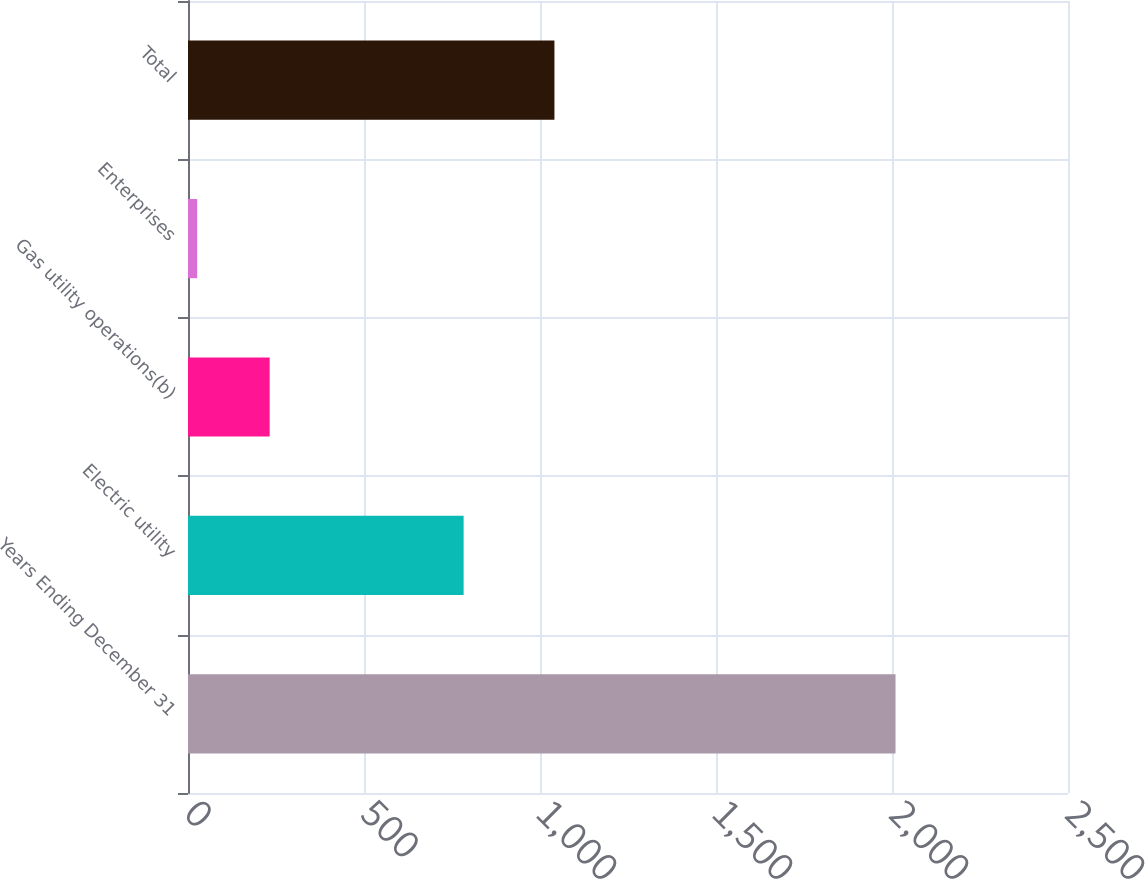Convert chart to OTSL. <chart><loc_0><loc_0><loc_500><loc_500><bar_chart><fcel>Years Ending December 31<fcel>Electric utility<fcel>Gas utility operations(b)<fcel>Enterprises<fcel>Total<nl><fcel>2010<fcel>783<fcel>232<fcel>26<fcel>1041<nl></chart> 